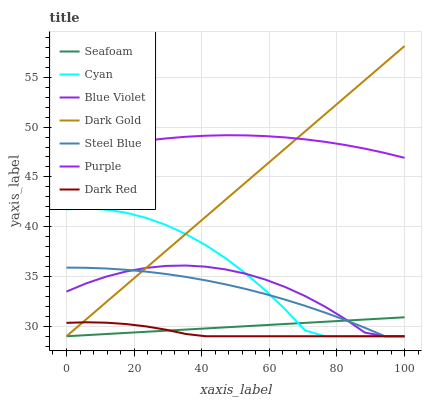Does Dark Red have the minimum area under the curve?
Answer yes or no. Yes. Does Purple have the maximum area under the curve?
Answer yes or no. Yes. Does Purple have the minimum area under the curve?
Answer yes or no. No. Does Dark Red have the maximum area under the curve?
Answer yes or no. No. Is Seafoam the smoothest?
Answer yes or no. Yes. Is Cyan the roughest?
Answer yes or no. Yes. Is Purple the smoothest?
Answer yes or no. No. Is Purple the roughest?
Answer yes or no. No. Does Dark Gold have the lowest value?
Answer yes or no. Yes. Does Purple have the lowest value?
Answer yes or no. No. Does Dark Gold have the highest value?
Answer yes or no. Yes. Does Purple have the highest value?
Answer yes or no. No. Is Seafoam less than Purple?
Answer yes or no. Yes. Is Purple greater than Seafoam?
Answer yes or no. Yes. Does Dark Gold intersect Dark Red?
Answer yes or no. Yes. Is Dark Gold less than Dark Red?
Answer yes or no. No. Is Dark Gold greater than Dark Red?
Answer yes or no. No. Does Seafoam intersect Purple?
Answer yes or no. No. 